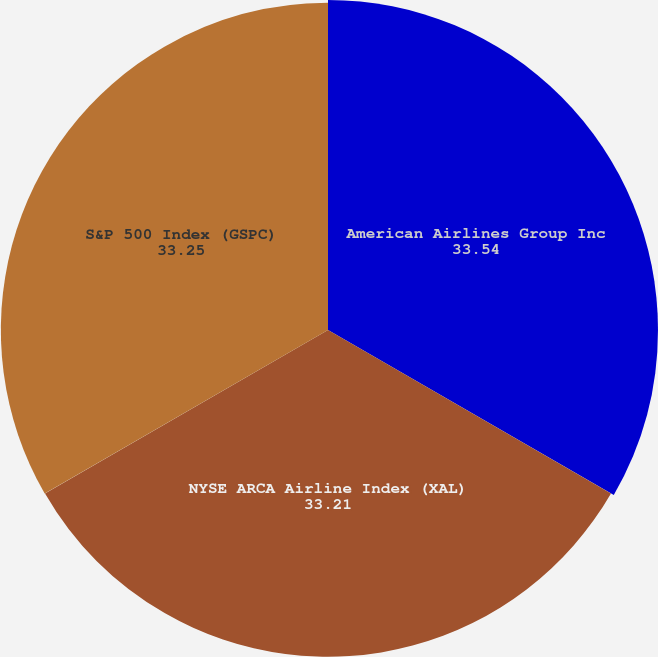Convert chart to OTSL. <chart><loc_0><loc_0><loc_500><loc_500><pie_chart><fcel>American Airlines Group Inc<fcel>NYSE ARCA Airline Index (XAL)<fcel>S&P 500 Index (GSPC)<nl><fcel>33.54%<fcel>33.21%<fcel>33.25%<nl></chart> 